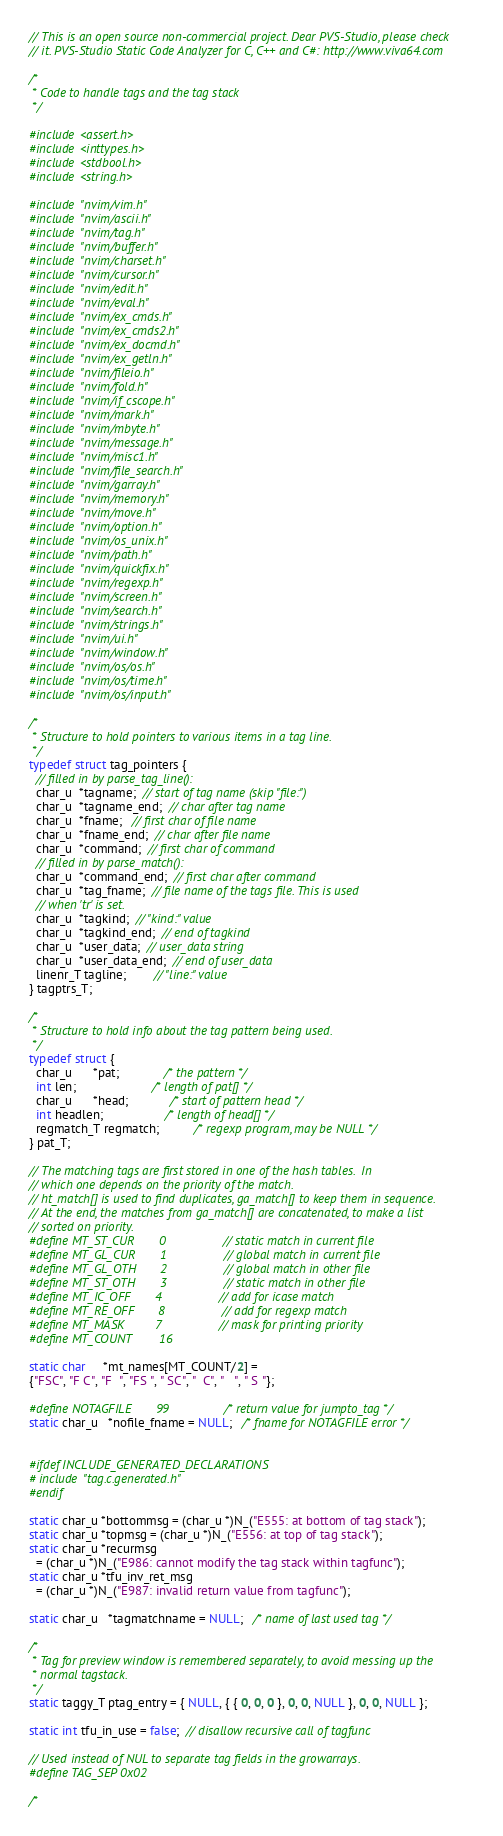<code> <loc_0><loc_0><loc_500><loc_500><_C_>// This is an open source non-commercial project. Dear PVS-Studio, please check
// it. PVS-Studio Static Code Analyzer for C, C++ and C#: http://www.viva64.com

/*
 * Code to handle tags and the tag stack
 */

#include <assert.h>
#include <inttypes.h>
#include <stdbool.h>
#include <string.h>

#include "nvim/vim.h"
#include "nvim/ascii.h"
#include "nvim/tag.h"
#include "nvim/buffer.h"
#include "nvim/charset.h"
#include "nvim/cursor.h"
#include "nvim/edit.h"
#include "nvim/eval.h"
#include "nvim/ex_cmds.h"
#include "nvim/ex_cmds2.h"
#include "nvim/ex_docmd.h"
#include "nvim/ex_getln.h"
#include "nvim/fileio.h"
#include "nvim/fold.h"
#include "nvim/if_cscope.h"
#include "nvim/mark.h"
#include "nvim/mbyte.h"
#include "nvim/message.h"
#include "nvim/misc1.h"
#include "nvim/file_search.h"
#include "nvim/garray.h"
#include "nvim/memory.h"
#include "nvim/move.h"
#include "nvim/option.h"
#include "nvim/os_unix.h"
#include "nvim/path.h"
#include "nvim/quickfix.h"
#include "nvim/regexp.h"
#include "nvim/screen.h"
#include "nvim/search.h"
#include "nvim/strings.h"
#include "nvim/ui.h"
#include "nvim/window.h"
#include "nvim/os/os.h"
#include "nvim/os/time.h"
#include "nvim/os/input.h"

/*
 * Structure to hold pointers to various items in a tag line.
 */
typedef struct tag_pointers {
  // filled in by parse_tag_line():
  char_u  *tagname;  // start of tag name (skip "file:")
  char_u  *tagname_end;  // char after tag name
  char_u  *fname;   // first char of file name
  char_u  *fname_end;  // char after file name
  char_u  *command;  // first char of command
  // filled in by parse_match():
  char_u  *command_end;  // first char after command
  char_u  *tag_fname;  // file name of the tags file. This is used
  // when 'tr' is set.
  char_u  *tagkind;  // "kind:" value
  char_u  *tagkind_end;  // end of tagkind
  char_u  *user_data;  // user_data string
  char_u  *user_data_end;  // end of user_data
  linenr_T tagline;        // "line:" value
} tagptrs_T;

/*
 * Structure to hold info about the tag pattern being used.
 */
typedef struct {
  char_u      *pat;             /* the pattern */
  int len;                      /* length of pat[] */
  char_u      *head;            /* start of pattern head */
  int headlen;                  /* length of head[] */
  regmatch_T regmatch;          /* regexp program, may be NULL */
} pat_T;

// The matching tags are first stored in one of the hash tables.  In
// which one depends on the priority of the match.
// ht_match[] is used to find duplicates, ga_match[] to keep them in sequence.
// At the end, the matches from ga_match[] are concatenated, to make a list
// sorted on priority.
#define MT_ST_CUR       0               // static match in current file
#define MT_GL_CUR       1               // global match in current file
#define MT_GL_OTH       2               // global match in other file
#define MT_ST_OTH       3               // static match in other file
#define MT_IC_OFF       4               // add for icase match
#define MT_RE_OFF       8               // add for regexp match
#define MT_MASK         7               // mask for printing priority
#define MT_COUNT        16

static char     *mt_names[MT_COUNT/2] =
{"FSC", "F C", "F  ", "FS ", " SC", "  C", "   ", " S "};

#define NOTAGFILE       99              /* return value for jumpto_tag */
static char_u   *nofile_fname = NULL;   /* fname for NOTAGFILE error */


#ifdef INCLUDE_GENERATED_DECLARATIONS
# include "tag.c.generated.h"
#endif

static char_u *bottommsg = (char_u *)N_("E555: at bottom of tag stack");
static char_u *topmsg = (char_u *)N_("E556: at top of tag stack");
static char_u *recurmsg
  = (char_u *)N_("E986: cannot modify the tag stack within tagfunc");
static char_u *tfu_inv_ret_msg
  = (char_u *)N_("E987: invalid return value from tagfunc");

static char_u   *tagmatchname = NULL;   /* name of last used tag */

/*
 * Tag for preview window is remembered separately, to avoid messing up the
 * normal tagstack.
 */
static taggy_T ptag_entry = { NULL, { { 0, 0, 0 }, 0, 0, NULL }, 0, 0, NULL };

static int tfu_in_use = false;  // disallow recursive call of tagfunc

// Used instead of NUL to separate tag fields in the growarrays.
#define TAG_SEP 0x02

/*</code> 